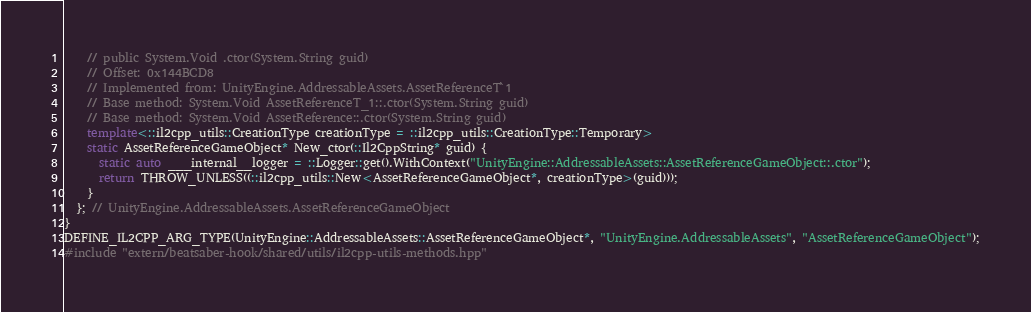<code> <loc_0><loc_0><loc_500><loc_500><_C++_>    // public System.Void .ctor(System.String guid)
    // Offset: 0x144BCD8
    // Implemented from: UnityEngine.AddressableAssets.AssetReferenceT`1
    // Base method: System.Void AssetReferenceT_1::.ctor(System.String guid)
    // Base method: System.Void AssetReference::.ctor(System.String guid)
    template<::il2cpp_utils::CreationType creationType = ::il2cpp_utils::CreationType::Temporary>
    static AssetReferenceGameObject* New_ctor(::Il2CppString* guid) {
      static auto ___internal__logger = ::Logger::get().WithContext("UnityEngine::AddressableAssets::AssetReferenceGameObject::.ctor");
      return THROW_UNLESS((::il2cpp_utils::New<AssetReferenceGameObject*, creationType>(guid)));
    }
  }; // UnityEngine.AddressableAssets.AssetReferenceGameObject
}
DEFINE_IL2CPP_ARG_TYPE(UnityEngine::AddressableAssets::AssetReferenceGameObject*, "UnityEngine.AddressableAssets", "AssetReferenceGameObject");
#include "extern/beatsaber-hook/shared/utils/il2cpp-utils-methods.hpp"</code> 